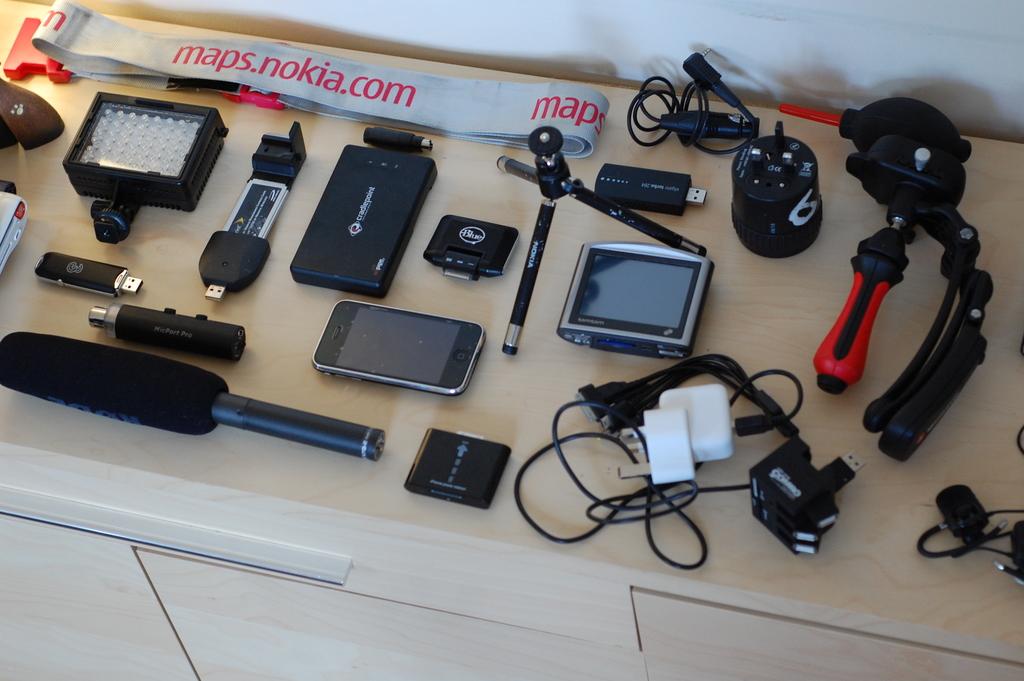What website is featured on the strap?
Your response must be concise. Maps.nokia.com. What brand is the tripod?
Ensure brevity in your answer.  Nokia. 